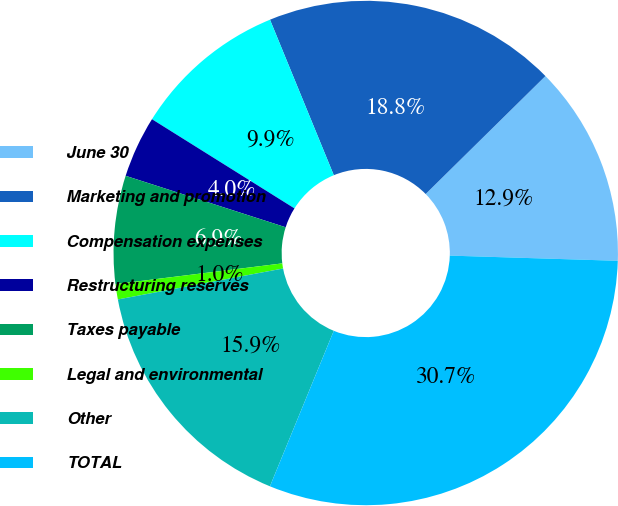Convert chart. <chart><loc_0><loc_0><loc_500><loc_500><pie_chart><fcel>June 30<fcel>Marketing and promotion<fcel>Compensation expenses<fcel>Restructuring reserves<fcel>Taxes payable<fcel>Legal and environmental<fcel>Other<fcel>TOTAL<nl><fcel>12.87%<fcel>18.82%<fcel>9.9%<fcel>3.95%<fcel>6.92%<fcel>0.98%<fcel>15.85%<fcel>30.71%<nl></chart> 